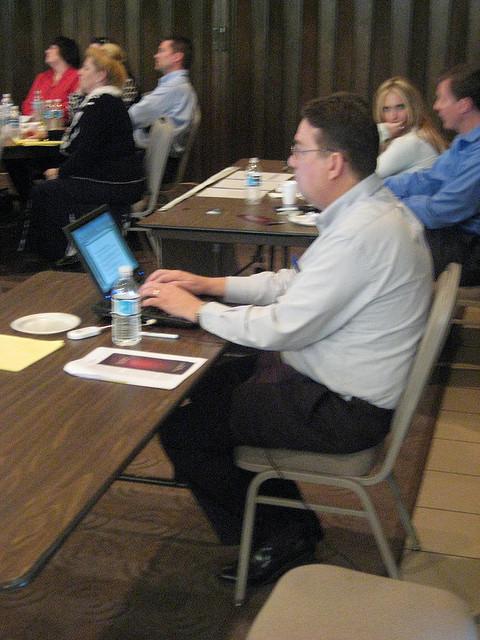What is the man sitting on?
Give a very brief answer. Chair. Are these people in training?
Keep it brief. Yes. Are they happy?
Give a very brief answer. No. Who is sitting next to the man with the laptop?
Keep it brief. No one. Does the man look like he's doing something interesting?
Give a very brief answer. No. 